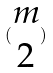Convert formula to latex. <formula><loc_0><loc_0><loc_500><loc_500>( \begin{matrix} m \\ 2 \end{matrix} )</formula> 